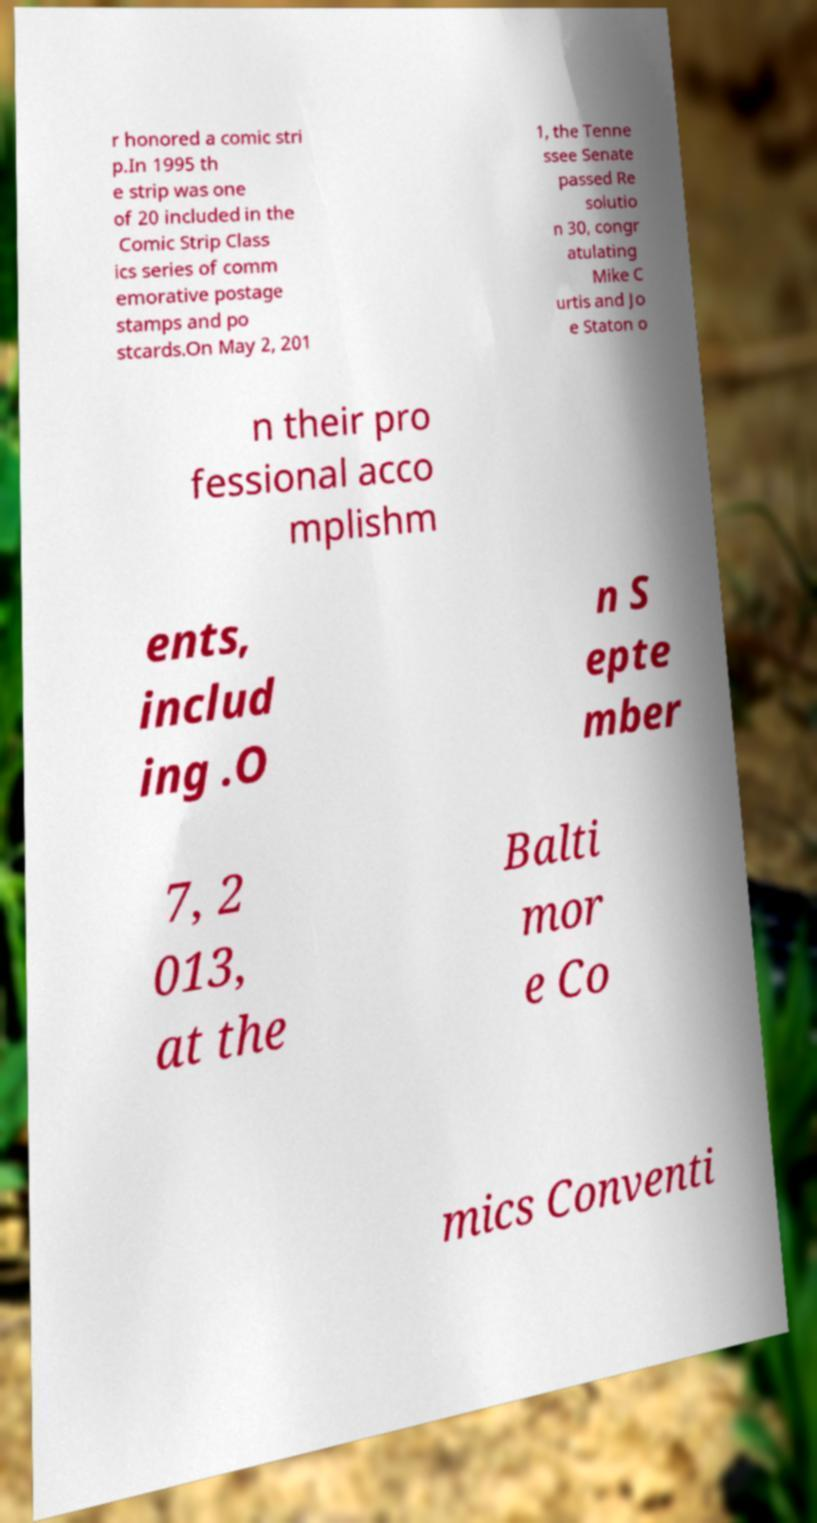Could you extract and type out the text from this image? r honored a comic stri p.In 1995 th e strip was one of 20 included in the Comic Strip Class ics series of comm emorative postage stamps and po stcards.On May 2, 201 1, the Tenne ssee Senate passed Re solutio n 30, congr atulating Mike C urtis and Jo e Staton o n their pro fessional acco mplishm ents, includ ing .O n S epte mber 7, 2 013, at the Balti mor e Co mics Conventi 